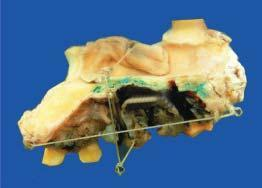what shows an elevated blackish ulcerated area with irregular outlines?
Answer the question using a single word or phrase. Hemimaxillectomy specimen 